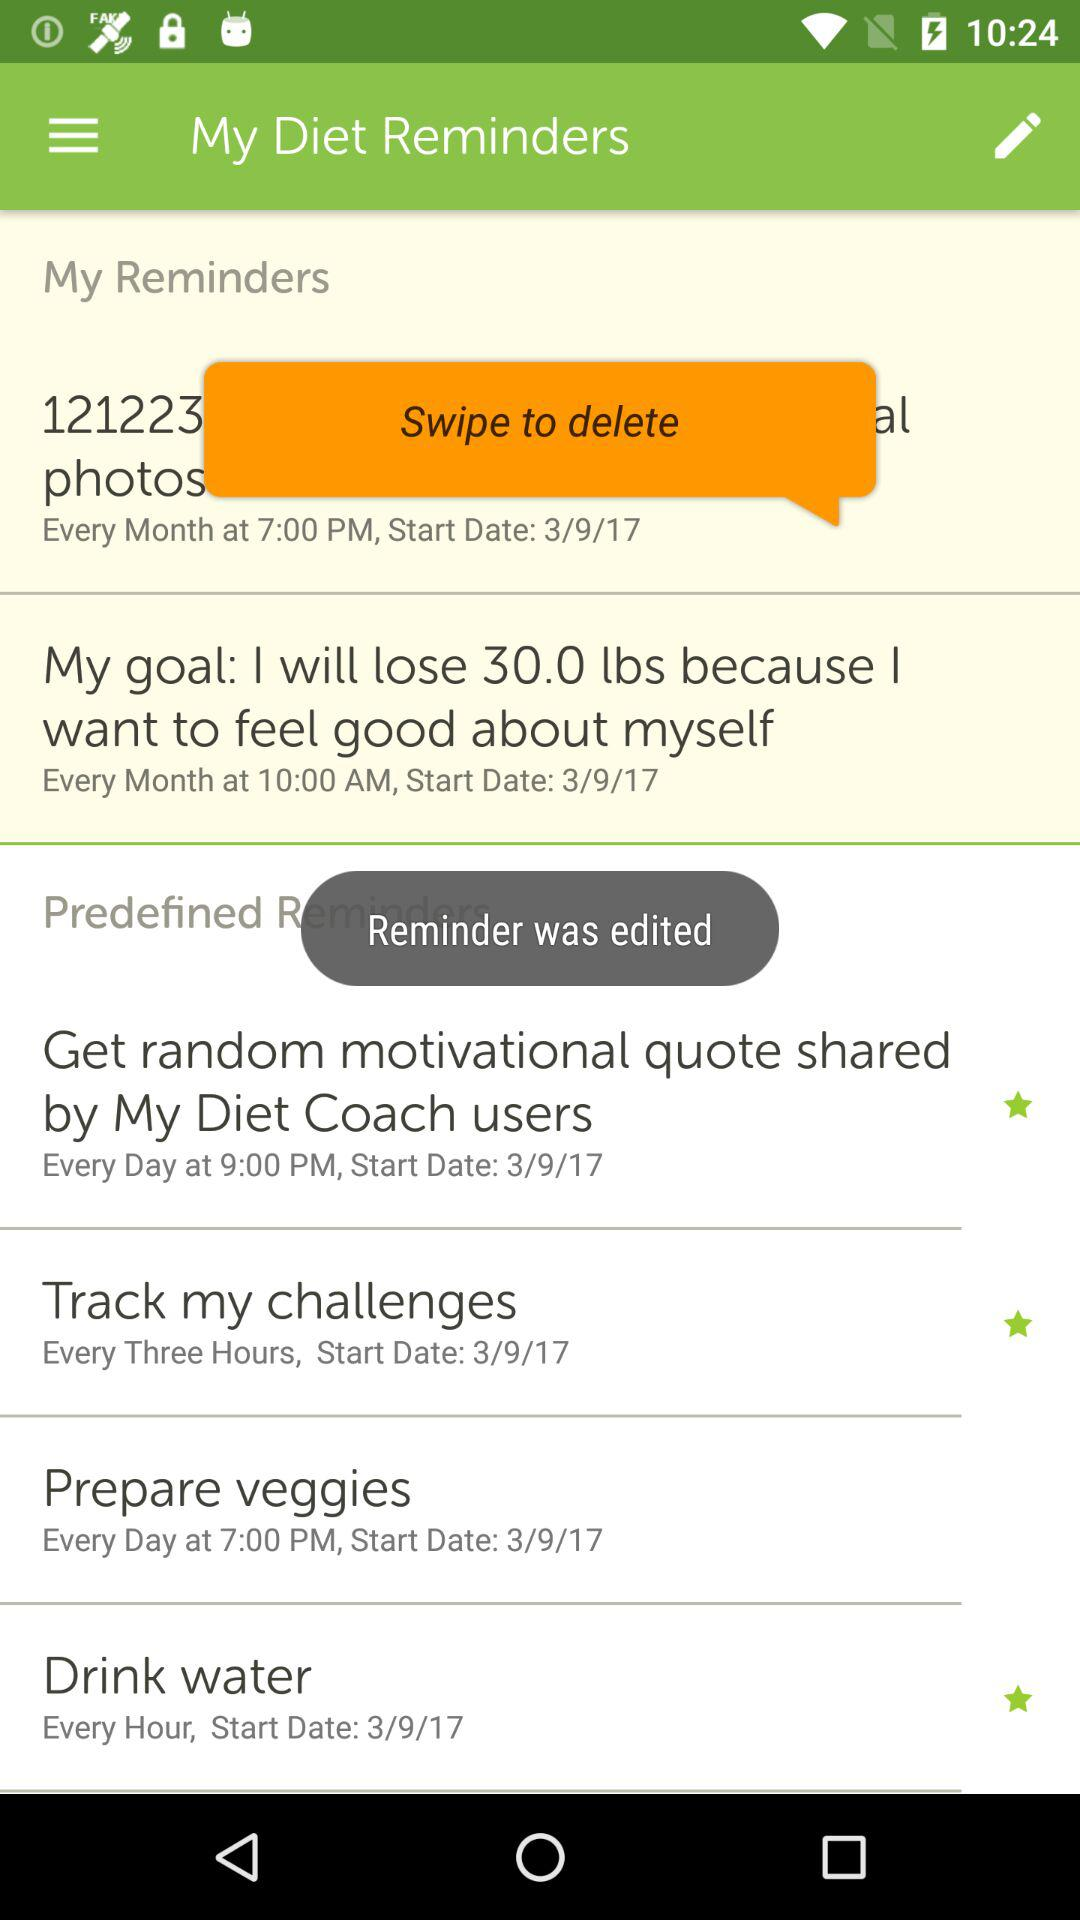What is the set reminder for "Drink water"? The set reminder for "Drink water" is every hour. 